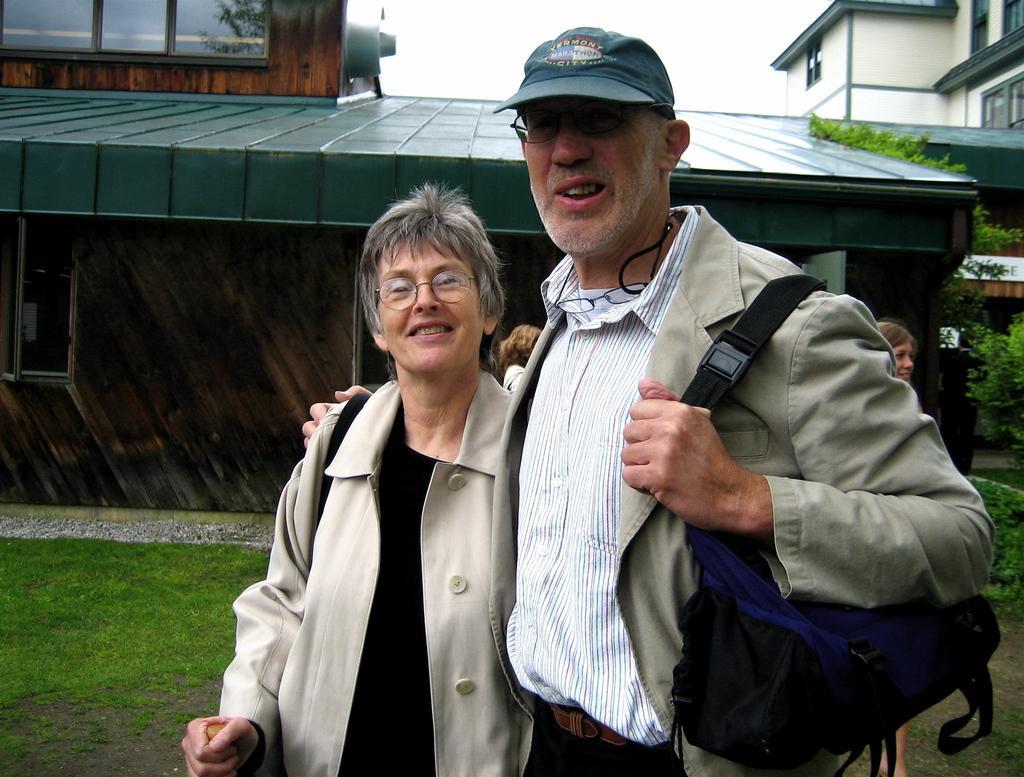Describe this image in one or two sentences. There is one woman and a man standing at the bottom of this image and we can see buildings and trees in the background. There is a sky at the top of this image. The person standing on the right side is holding a backpack. 